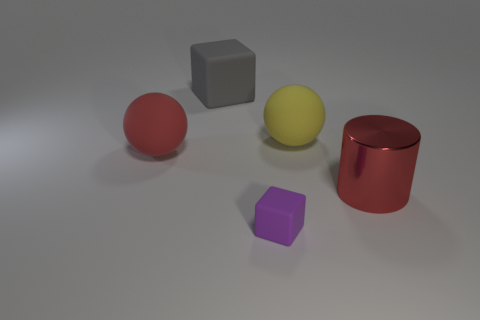Is there anything else that has the same material as the large red cylinder?
Your response must be concise. No. Are the tiny purple thing and the block that is behind the red rubber sphere made of the same material?
Offer a very short reply. Yes. How many things are either big balls behind the large red rubber object or red metal objects?
Your answer should be very brief. 2. There is a object that is both in front of the large yellow ball and behind the large shiny object; what shape is it?
Ensure brevity in your answer.  Sphere. Are there any other things that have the same size as the gray cube?
Make the answer very short. Yes. What size is the yellow object that is made of the same material as the big gray object?
Your answer should be compact. Large. How many things are big spheres right of the large gray cube or rubber spheres on the left side of the purple matte cube?
Offer a terse response. 2. Does the red rubber ball on the left side of the gray rubber object have the same size as the big gray thing?
Provide a short and direct response. Yes. What color is the rubber block that is behind the large yellow thing?
Give a very brief answer. Gray. The other thing that is the same shape as the purple thing is what color?
Provide a short and direct response. Gray. 